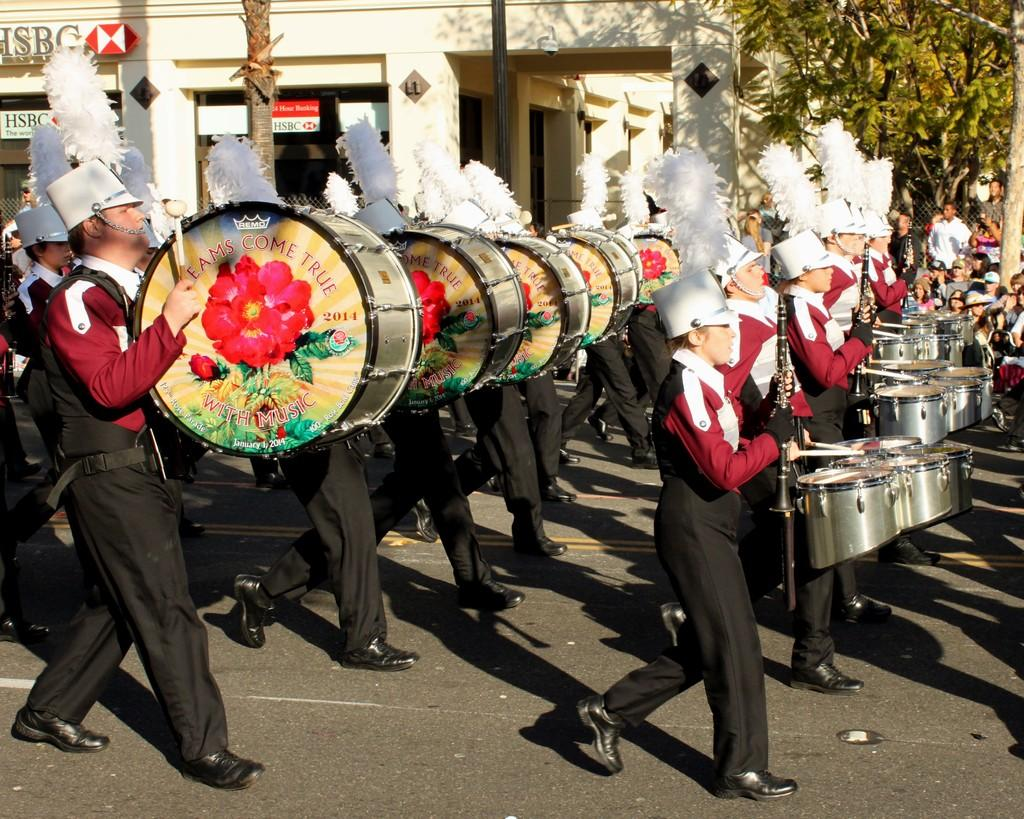Where is the image taken? The image is taken outside a building. What are the people in the image doing? The people are playing drums. What are the people wearing? The people are wearing uniforms and white hats. What can be seen in the background of the image? There is a tree and a building in the background of the image. How does the wax affect the pollution in the image? There is no mention of wax or pollution in the image, so it is not possible to determine any effects. 